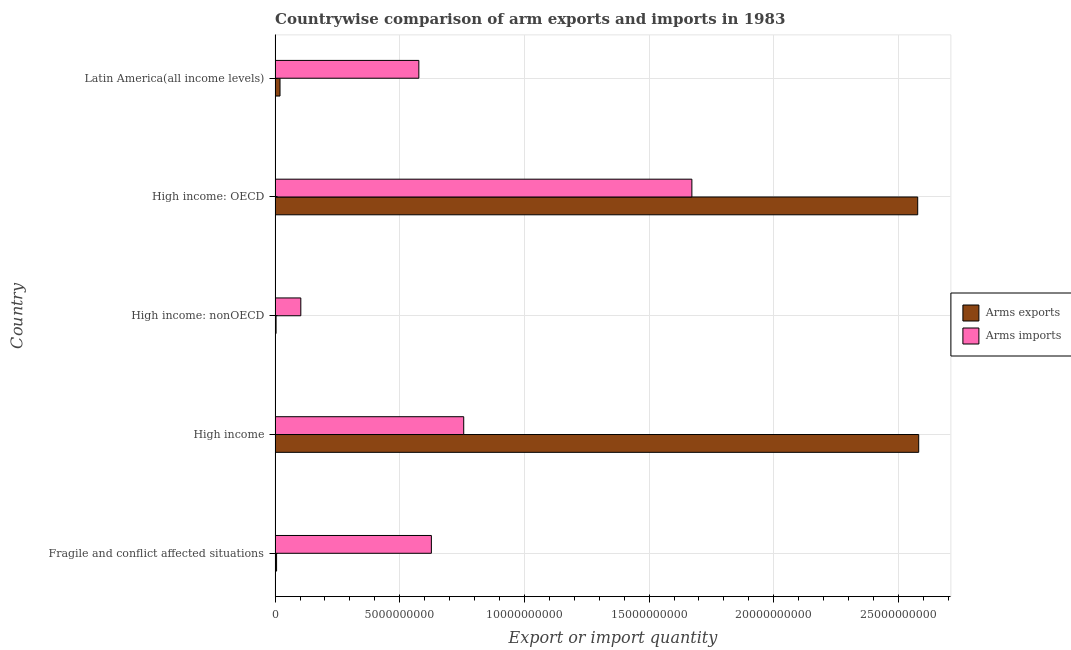How many different coloured bars are there?
Provide a short and direct response. 2. How many groups of bars are there?
Provide a short and direct response. 5. How many bars are there on the 3rd tick from the bottom?
Offer a very short reply. 2. What is the label of the 1st group of bars from the top?
Provide a short and direct response. Latin America(all income levels). What is the arms exports in Fragile and conflict affected situations?
Provide a short and direct response. 6.00e+07. Across all countries, what is the maximum arms imports?
Offer a very short reply. 1.67e+1. Across all countries, what is the minimum arms exports?
Keep it short and to the point. 4.00e+07. In which country was the arms exports maximum?
Keep it short and to the point. High income. In which country was the arms imports minimum?
Give a very brief answer. High income: nonOECD. What is the total arms imports in the graph?
Ensure brevity in your answer.  3.74e+1. What is the difference between the arms imports in Fragile and conflict affected situations and that in High income: nonOECD?
Offer a very short reply. 5.24e+09. What is the difference between the arms imports in High income: nonOECD and the arms exports in Latin America(all income levels)?
Your answer should be compact. 8.34e+08. What is the average arms imports per country?
Provide a succinct answer. 7.47e+09. What is the difference between the arms imports and arms exports in Latin America(all income levels)?
Offer a very short reply. 5.57e+09. What is the ratio of the arms exports in Fragile and conflict affected situations to that in Latin America(all income levels)?
Keep it short and to the point. 0.3. Is the difference between the arms imports in High income: nonOECD and Latin America(all income levels) greater than the difference between the arms exports in High income: nonOECD and Latin America(all income levels)?
Your answer should be very brief. No. What is the difference between the highest and the second highest arms imports?
Offer a very short reply. 9.15e+09. What is the difference between the highest and the lowest arms imports?
Give a very brief answer. 1.57e+1. In how many countries, is the arms exports greater than the average arms exports taken over all countries?
Your response must be concise. 2. Is the sum of the arms imports in Fragile and conflict affected situations and Latin America(all income levels) greater than the maximum arms exports across all countries?
Offer a terse response. No. What does the 2nd bar from the top in High income: OECD represents?
Keep it short and to the point. Arms exports. What does the 2nd bar from the bottom in Fragile and conflict affected situations represents?
Keep it short and to the point. Arms imports. How many bars are there?
Offer a very short reply. 10. What is the difference between two consecutive major ticks on the X-axis?
Keep it short and to the point. 5.00e+09. Are the values on the major ticks of X-axis written in scientific E-notation?
Make the answer very short. No. Does the graph contain any zero values?
Ensure brevity in your answer.  No. Does the graph contain grids?
Offer a very short reply. Yes. How are the legend labels stacked?
Provide a succinct answer. Vertical. What is the title of the graph?
Your answer should be compact. Countrywise comparison of arm exports and imports in 1983. What is the label or title of the X-axis?
Provide a short and direct response. Export or import quantity. What is the Export or import quantity in Arms exports in Fragile and conflict affected situations?
Offer a very short reply. 6.00e+07. What is the Export or import quantity in Arms imports in Fragile and conflict affected situations?
Offer a very short reply. 6.27e+09. What is the Export or import quantity in Arms exports in High income?
Ensure brevity in your answer.  2.58e+1. What is the Export or import quantity of Arms imports in High income?
Your answer should be very brief. 7.57e+09. What is the Export or import quantity of Arms exports in High income: nonOECD?
Offer a terse response. 4.00e+07. What is the Export or import quantity in Arms imports in High income: nonOECD?
Make the answer very short. 1.03e+09. What is the Export or import quantity of Arms exports in High income: OECD?
Provide a succinct answer. 2.58e+1. What is the Export or import quantity of Arms imports in High income: OECD?
Offer a very short reply. 1.67e+1. What is the Export or import quantity of Arms exports in Latin America(all income levels)?
Offer a terse response. 1.98e+08. What is the Export or import quantity in Arms imports in Latin America(all income levels)?
Give a very brief answer. 5.77e+09. Across all countries, what is the maximum Export or import quantity of Arms exports?
Make the answer very short. 2.58e+1. Across all countries, what is the maximum Export or import quantity in Arms imports?
Your response must be concise. 1.67e+1. Across all countries, what is the minimum Export or import quantity in Arms exports?
Give a very brief answer. 4.00e+07. Across all countries, what is the minimum Export or import quantity in Arms imports?
Give a very brief answer. 1.03e+09. What is the total Export or import quantity of Arms exports in the graph?
Give a very brief answer. 5.19e+1. What is the total Export or import quantity of Arms imports in the graph?
Keep it short and to the point. 3.74e+1. What is the difference between the Export or import quantity of Arms exports in Fragile and conflict affected situations and that in High income?
Offer a terse response. -2.58e+1. What is the difference between the Export or import quantity of Arms imports in Fragile and conflict affected situations and that in High income?
Offer a terse response. -1.30e+09. What is the difference between the Export or import quantity of Arms exports in Fragile and conflict affected situations and that in High income: nonOECD?
Offer a very short reply. 2.00e+07. What is the difference between the Export or import quantity of Arms imports in Fragile and conflict affected situations and that in High income: nonOECD?
Keep it short and to the point. 5.24e+09. What is the difference between the Export or import quantity of Arms exports in Fragile and conflict affected situations and that in High income: OECD?
Your response must be concise. -2.57e+1. What is the difference between the Export or import quantity of Arms imports in Fragile and conflict affected situations and that in High income: OECD?
Your answer should be compact. -1.04e+1. What is the difference between the Export or import quantity of Arms exports in Fragile and conflict affected situations and that in Latin America(all income levels)?
Give a very brief answer. -1.38e+08. What is the difference between the Export or import quantity in Arms imports in Fragile and conflict affected situations and that in Latin America(all income levels)?
Make the answer very short. 5.03e+08. What is the difference between the Export or import quantity of Arms exports in High income and that in High income: nonOECD?
Offer a very short reply. 2.58e+1. What is the difference between the Export or import quantity in Arms imports in High income and that in High income: nonOECD?
Provide a short and direct response. 6.53e+09. What is the difference between the Export or import quantity of Arms exports in High income and that in High income: OECD?
Your response must be concise. 4.00e+07. What is the difference between the Export or import quantity of Arms imports in High income and that in High income: OECD?
Make the answer very short. -9.15e+09. What is the difference between the Export or import quantity of Arms exports in High income and that in Latin America(all income levels)?
Give a very brief answer. 2.56e+1. What is the difference between the Export or import quantity in Arms imports in High income and that in Latin America(all income levels)?
Give a very brief answer. 1.80e+09. What is the difference between the Export or import quantity of Arms exports in High income: nonOECD and that in High income: OECD?
Ensure brevity in your answer.  -2.57e+1. What is the difference between the Export or import quantity of Arms imports in High income: nonOECD and that in High income: OECD?
Provide a short and direct response. -1.57e+1. What is the difference between the Export or import quantity in Arms exports in High income: nonOECD and that in Latin America(all income levels)?
Provide a succinct answer. -1.58e+08. What is the difference between the Export or import quantity of Arms imports in High income: nonOECD and that in Latin America(all income levels)?
Offer a very short reply. -4.73e+09. What is the difference between the Export or import quantity of Arms exports in High income: OECD and that in Latin America(all income levels)?
Offer a terse response. 2.56e+1. What is the difference between the Export or import quantity in Arms imports in High income: OECD and that in Latin America(all income levels)?
Make the answer very short. 1.10e+1. What is the difference between the Export or import quantity of Arms exports in Fragile and conflict affected situations and the Export or import quantity of Arms imports in High income?
Keep it short and to the point. -7.51e+09. What is the difference between the Export or import quantity in Arms exports in Fragile and conflict affected situations and the Export or import quantity in Arms imports in High income: nonOECD?
Provide a short and direct response. -9.72e+08. What is the difference between the Export or import quantity in Arms exports in Fragile and conflict affected situations and the Export or import quantity in Arms imports in High income: OECD?
Your answer should be compact. -1.67e+1. What is the difference between the Export or import quantity of Arms exports in Fragile and conflict affected situations and the Export or import quantity of Arms imports in Latin America(all income levels)?
Ensure brevity in your answer.  -5.71e+09. What is the difference between the Export or import quantity of Arms exports in High income and the Export or import quantity of Arms imports in High income: nonOECD?
Keep it short and to the point. 2.48e+1. What is the difference between the Export or import quantity of Arms exports in High income and the Export or import quantity of Arms imports in High income: OECD?
Ensure brevity in your answer.  9.10e+09. What is the difference between the Export or import quantity in Arms exports in High income and the Export or import quantity in Arms imports in Latin America(all income levels)?
Keep it short and to the point. 2.00e+1. What is the difference between the Export or import quantity of Arms exports in High income: nonOECD and the Export or import quantity of Arms imports in High income: OECD?
Ensure brevity in your answer.  -1.67e+1. What is the difference between the Export or import quantity in Arms exports in High income: nonOECD and the Export or import quantity in Arms imports in Latin America(all income levels)?
Keep it short and to the point. -5.73e+09. What is the difference between the Export or import quantity in Arms exports in High income: OECD and the Export or import quantity in Arms imports in Latin America(all income levels)?
Your answer should be compact. 2.00e+1. What is the average Export or import quantity of Arms exports per country?
Make the answer very short. 1.04e+1. What is the average Export or import quantity in Arms imports per country?
Keep it short and to the point. 7.47e+09. What is the difference between the Export or import quantity of Arms exports and Export or import quantity of Arms imports in Fragile and conflict affected situations?
Your answer should be compact. -6.21e+09. What is the difference between the Export or import quantity of Arms exports and Export or import quantity of Arms imports in High income?
Provide a short and direct response. 1.82e+1. What is the difference between the Export or import quantity of Arms exports and Export or import quantity of Arms imports in High income: nonOECD?
Your answer should be compact. -9.92e+08. What is the difference between the Export or import quantity in Arms exports and Export or import quantity in Arms imports in High income: OECD?
Ensure brevity in your answer.  9.06e+09. What is the difference between the Export or import quantity in Arms exports and Export or import quantity in Arms imports in Latin America(all income levels)?
Provide a short and direct response. -5.57e+09. What is the ratio of the Export or import quantity of Arms exports in Fragile and conflict affected situations to that in High income?
Offer a terse response. 0. What is the ratio of the Export or import quantity of Arms imports in Fragile and conflict affected situations to that in High income?
Keep it short and to the point. 0.83. What is the ratio of the Export or import quantity in Arms exports in Fragile and conflict affected situations to that in High income: nonOECD?
Offer a very short reply. 1.5. What is the ratio of the Export or import quantity of Arms imports in Fragile and conflict affected situations to that in High income: nonOECD?
Offer a very short reply. 6.07. What is the ratio of the Export or import quantity of Arms exports in Fragile and conflict affected situations to that in High income: OECD?
Keep it short and to the point. 0. What is the ratio of the Export or import quantity of Arms exports in Fragile and conflict affected situations to that in Latin America(all income levels)?
Keep it short and to the point. 0.3. What is the ratio of the Export or import quantity in Arms imports in Fragile and conflict affected situations to that in Latin America(all income levels)?
Give a very brief answer. 1.09. What is the ratio of the Export or import quantity in Arms exports in High income to that in High income: nonOECD?
Make the answer very short. 645.38. What is the ratio of the Export or import quantity in Arms imports in High income to that in High income: nonOECD?
Ensure brevity in your answer.  7.33. What is the ratio of the Export or import quantity of Arms exports in High income to that in High income: OECD?
Keep it short and to the point. 1. What is the ratio of the Export or import quantity in Arms imports in High income to that in High income: OECD?
Make the answer very short. 0.45. What is the ratio of the Export or import quantity in Arms exports in High income to that in Latin America(all income levels)?
Keep it short and to the point. 130.38. What is the ratio of the Export or import quantity of Arms imports in High income to that in Latin America(all income levels)?
Offer a terse response. 1.31. What is the ratio of the Export or import quantity of Arms exports in High income: nonOECD to that in High income: OECD?
Your answer should be compact. 0. What is the ratio of the Export or import quantity in Arms imports in High income: nonOECD to that in High income: OECD?
Your answer should be very brief. 0.06. What is the ratio of the Export or import quantity of Arms exports in High income: nonOECD to that in Latin America(all income levels)?
Keep it short and to the point. 0.2. What is the ratio of the Export or import quantity in Arms imports in High income: nonOECD to that in Latin America(all income levels)?
Your response must be concise. 0.18. What is the ratio of the Export or import quantity in Arms exports in High income: OECD to that in Latin America(all income levels)?
Your answer should be compact. 130.18. What is the ratio of the Export or import quantity in Arms imports in High income: OECD to that in Latin America(all income levels)?
Provide a succinct answer. 2.9. What is the difference between the highest and the second highest Export or import quantity of Arms exports?
Your response must be concise. 4.00e+07. What is the difference between the highest and the second highest Export or import quantity of Arms imports?
Ensure brevity in your answer.  9.15e+09. What is the difference between the highest and the lowest Export or import quantity of Arms exports?
Keep it short and to the point. 2.58e+1. What is the difference between the highest and the lowest Export or import quantity in Arms imports?
Your answer should be very brief. 1.57e+1. 